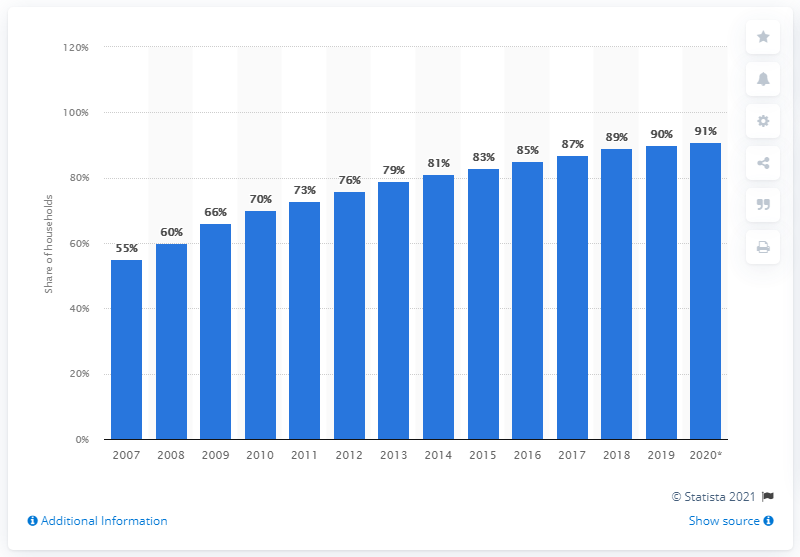Point out several critical features in this image. In 2020, 91% of EU households had internet access. According to the data, the share of EU households with internet access for the first time was 90% in 2013. 